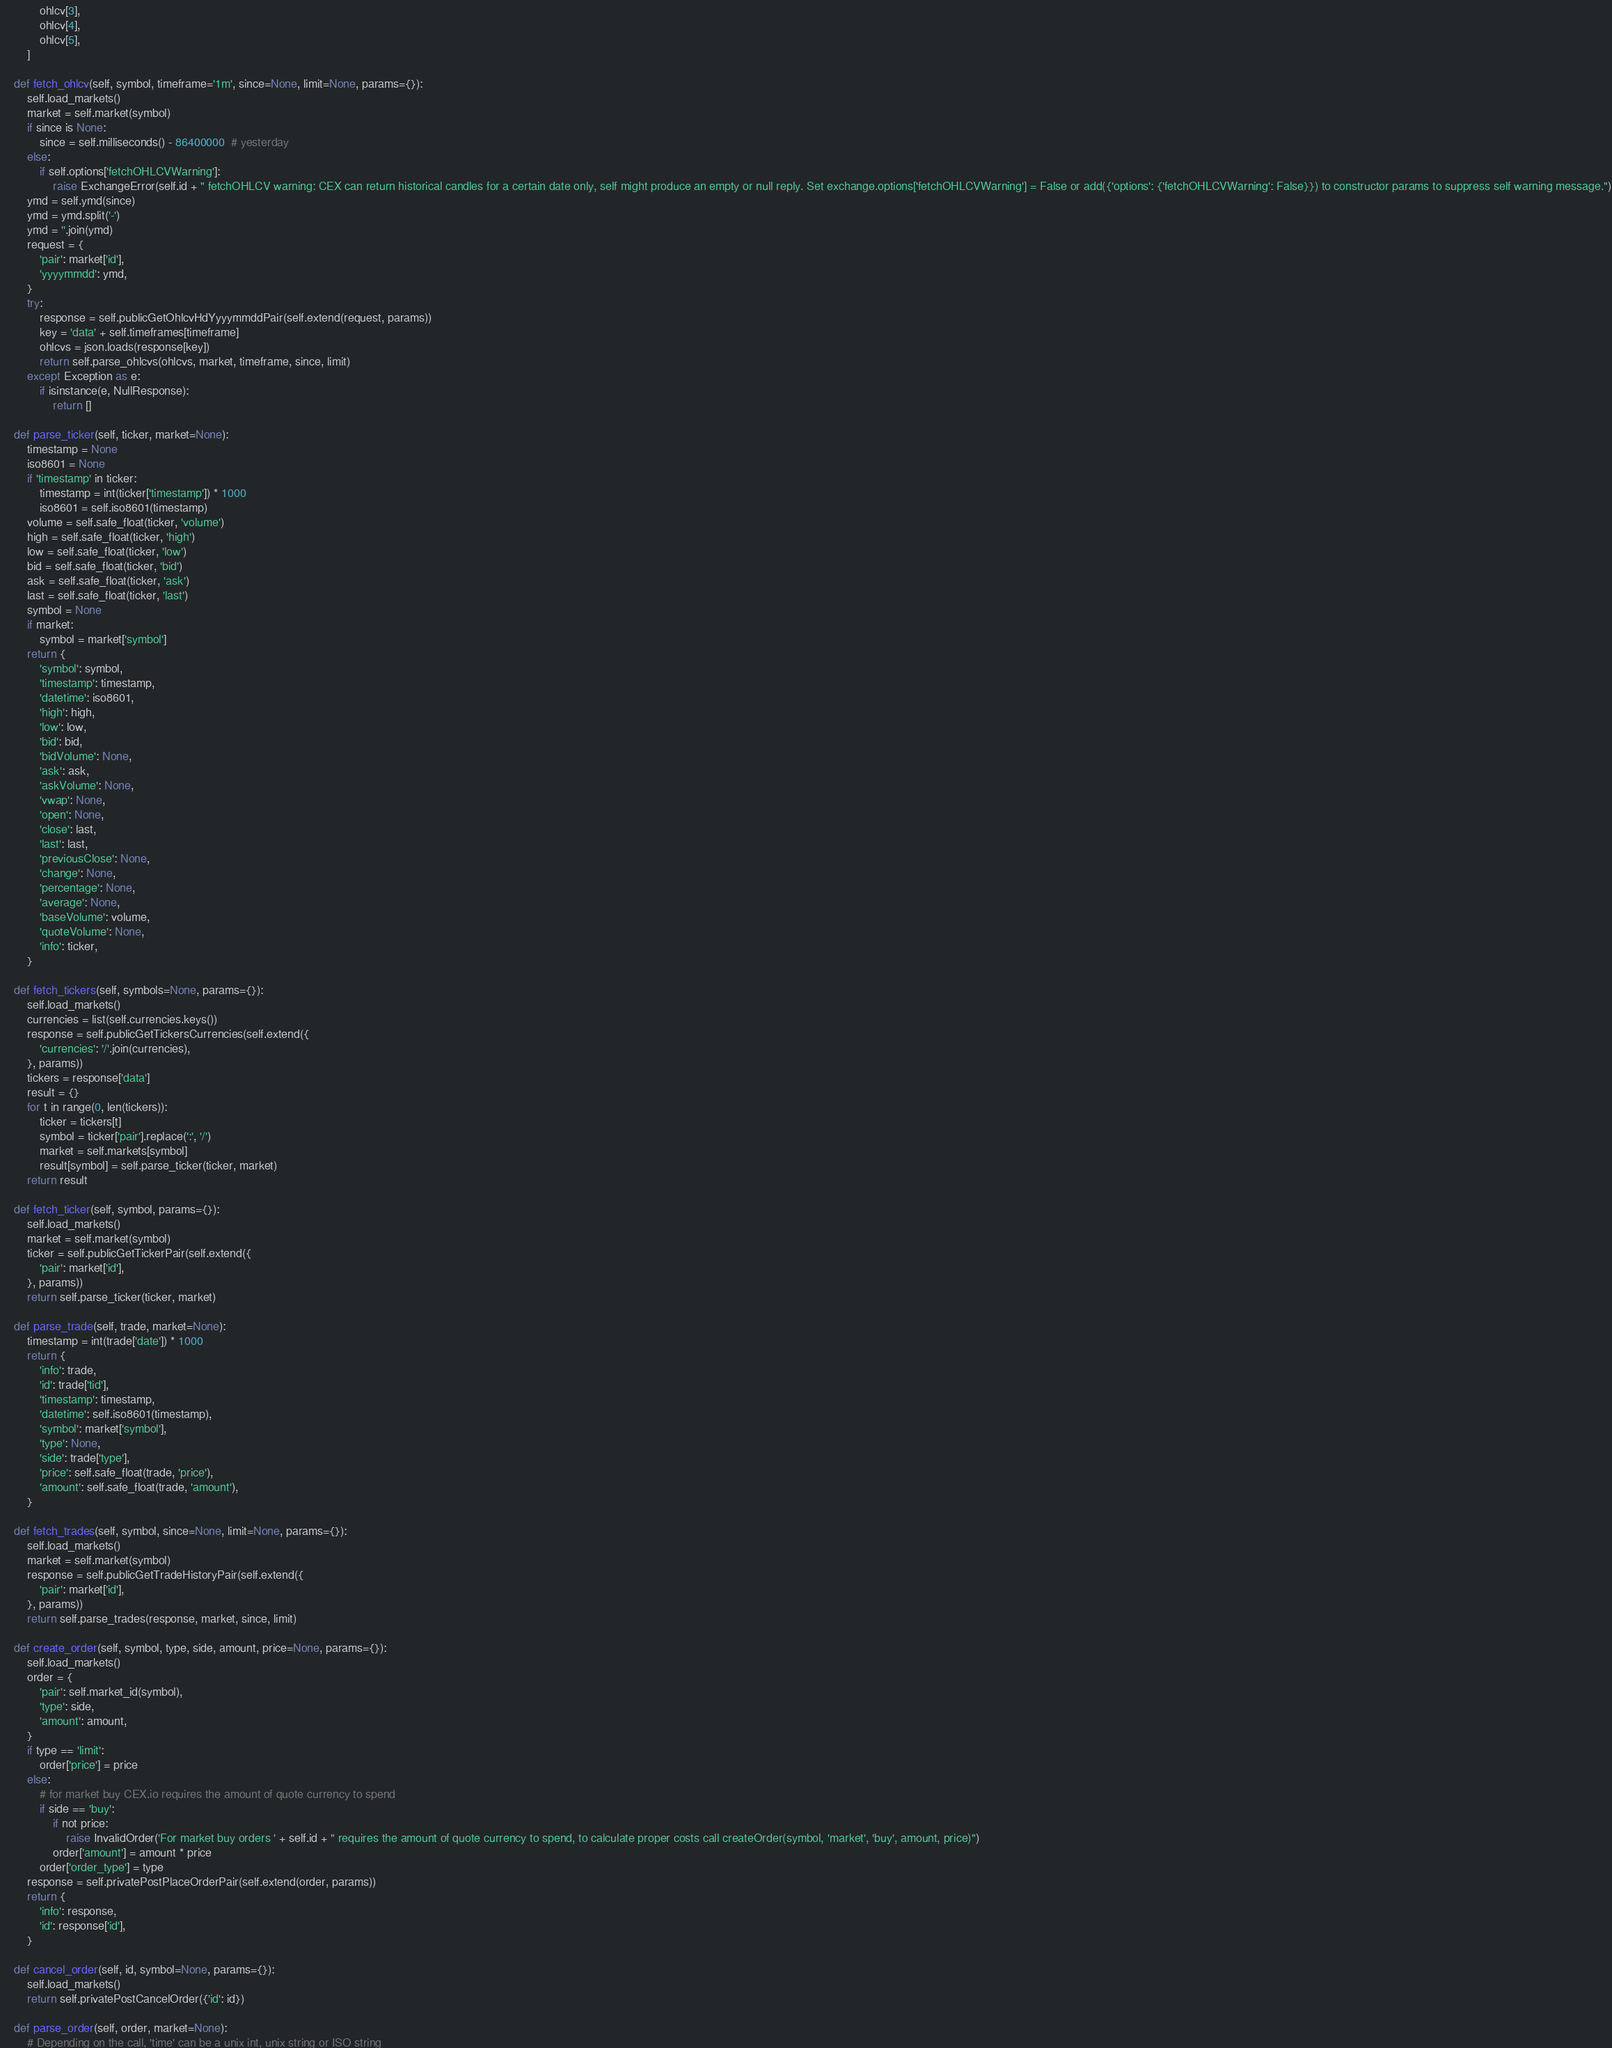<code> <loc_0><loc_0><loc_500><loc_500><_Python_>            ohlcv[3],
            ohlcv[4],
            ohlcv[5],
        ]

    def fetch_ohlcv(self, symbol, timeframe='1m', since=None, limit=None, params={}):
        self.load_markets()
        market = self.market(symbol)
        if since is None:
            since = self.milliseconds() - 86400000  # yesterday
        else:
            if self.options['fetchOHLCVWarning']:
                raise ExchangeError(self.id + " fetchOHLCV warning: CEX can return historical candles for a certain date only, self might produce an empty or null reply. Set exchange.options['fetchOHLCVWarning'] = False or add({'options': {'fetchOHLCVWarning': False}}) to constructor params to suppress self warning message.")
        ymd = self.ymd(since)
        ymd = ymd.split('-')
        ymd = ''.join(ymd)
        request = {
            'pair': market['id'],
            'yyyymmdd': ymd,
        }
        try:
            response = self.publicGetOhlcvHdYyyymmddPair(self.extend(request, params))
            key = 'data' + self.timeframes[timeframe]
            ohlcvs = json.loads(response[key])
            return self.parse_ohlcvs(ohlcvs, market, timeframe, since, limit)
        except Exception as e:
            if isinstance(e, NullResponse):
                return []

    def parse_ticker(self, ticker, market=None):
        timestamp = None
        iso8601 = None
        if 'timestamp' in ticker:
            timestamp = int(ticker['timestamp']) * 1000
            iso8601 = self.iso8601(timestamp)
        volume = self.safe_float(ticker, 'volume')
        high = self.safe_float(ticker, 'high')
        low = self.safe_float(ticker, 'low')
        bid = self.safe_float(ticker, 'bid')
        ask = self.safe_float(ticker, 'ask')
        last = self.safe_float(ticker, 'last')
        symbol = None
        if market:
            symbol = market['symbol']
        return {
            'symbol': symbol,
            'timestamp': timestamp,
            'datetime': iso8601,
            'high': high,
            'low': low,
            'bid': bid,
            'bidVolume': None,
            'ask': ask,
            'askVolume': None,
            'vwap': None,
            'open': None,
            'close': last,
            'last': last,
            'previousClose': None,
            'change': None,
            'percentage': None,
            'average': None,
            'baseVolume': volume,
            'quoteVolume': None,
            'info': ticker,
        }

    def fetch_tickers(self, symbols=None, params={}):
        self.load_markets()
        currencies = list(self.currencies.keys())
        response = self.publicGetTickersCurrencies(self.extend({
            'currencies': '/'.join(currencies),
        }, params))
        tickers = response['data']
        result = {}
        for t in range(0, len(tickers)):
            ticker = tickers[t]
            symbol = ticker['pair'].replace(':', '/')
            market = self.markets[symbol]
            result[symbol] = self.parse_ticker(ticker, market)
        return result

    def fetch_ticker(self, symbol, params={}):
        self.load_markets()
        market = self.market(symbol)
        ticker = self.publicGetTickerPair(self.extend({
            'pair': market['id'],
        }, params))
        return self.parse_ticker(ticker, market)

    def parse_trade(self, trade, market=None):
        timestamp = int(trade['date']) * 1000
        return {
            'info': trade,
            'id': trade['tid'],
            'timestamp': timestamp,
            'datetime': self.iso8601(timestamp),
            'symbol': market['symbol'],
            'type': None,
            'side': trade['type'],
            'price': self.safe_float(trade, 'price'),
            'amount': self.safe_float(trade, 'amount'),
        }

    def fetch_trades(self, symbol, since=None, limit=None, params={}):
        self.load_markets()
        market = self.market(symbol)
        response = self.publicGetTradeHistoryPair(self.extend({
            'pair': market['id'],
        }, params))
        return self.parse_trades(response, market, since, limit)

    def create_order(self, symbol, type, side, amount, price=None, params={}):
        self.load_markets()
        order = {
            'pair': self.market_id(symbol),
            'type': side,
            'amount': amount,
        }
        if type == 'limit':
            order['price'] = price
        else:
            # for market buy CEX.io requires the amount of quote currency to spend
            if side == 'buy':
                if not price:
                    raise InvalidOrder('For market buy orders ' + self.id + " requires the amount of quote currency to spend, to calculate proper costs call createOrder(symbol, 'market', 'buy', amount, price)")
                order['amount'] = amount * price
            order['order_type'] = type
        response = self.privatePostPlaceOrderPair(self.extend(order, params))
        return {
            'info': response,
            'id': response['id'],
        }

    def cancel_order(self, id, symbol=None, params={}):
        self.load_markets()
        return self.privatePostCancelOrder({'id': id})

    def parse_order(self, order, market=None):
        # Depending on the call, 'time' can be a unix int, unix string or ISO string</code> 